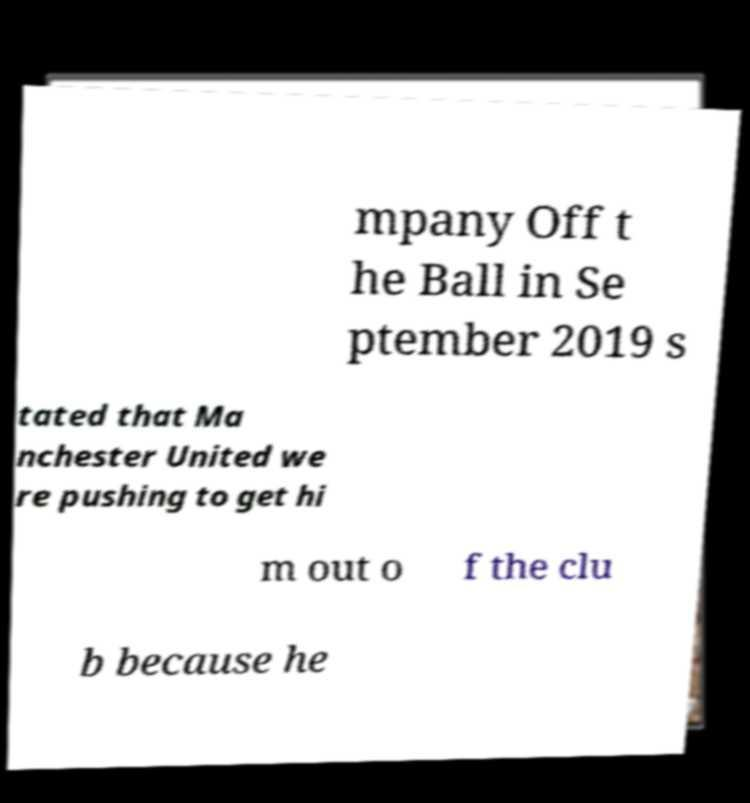For documentation purposes, I need the text within this image transcribed. Could you provide that? mpany Off t he Ball in Se ptember 2019 s tated that Ma nchester United we re pushing to get hi m out o f the clu b because he 